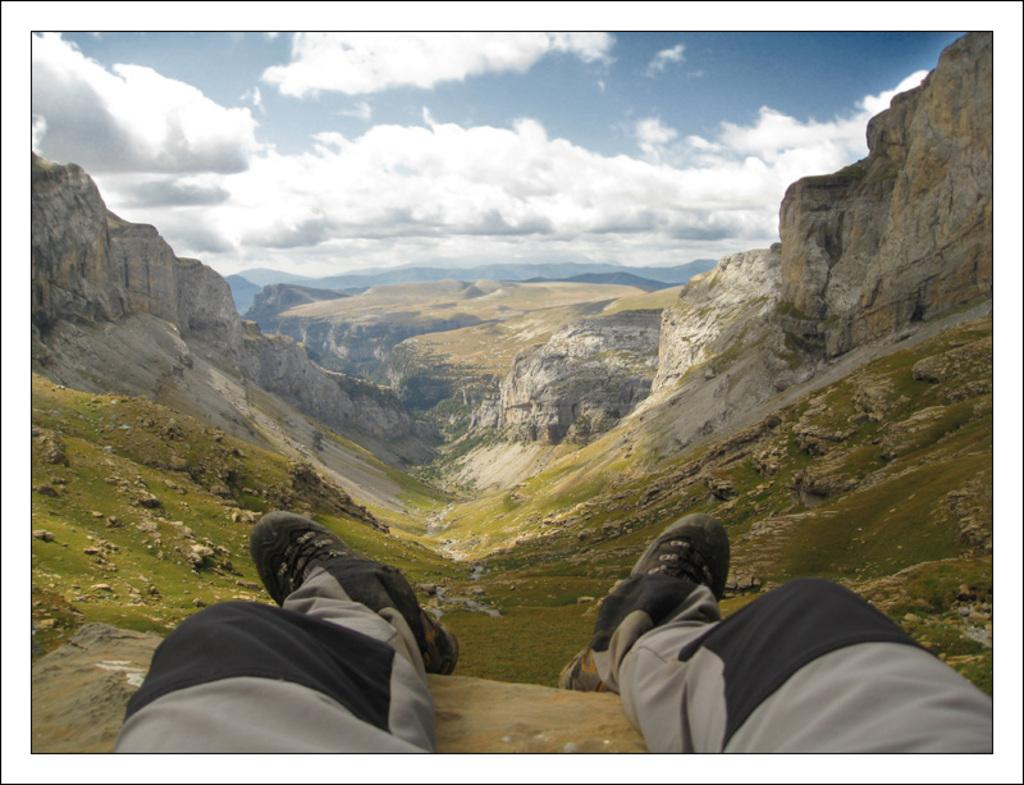What part of a person is visible in the image? There are a person's legs visible in the image. What type of footwear is the person wearing? The person is wearing black shoes. What type of landscape can be seen in the background of the image? Mountains are visible in the background of the image. What is the condition of the sky in the background of the image? The sky is clear in the background of the image. How many kittens can be seen playing in the mountains in the image? There are no kittens visible in the image; only a person's legs, black shoes, mountains, and a clear sky are present. 